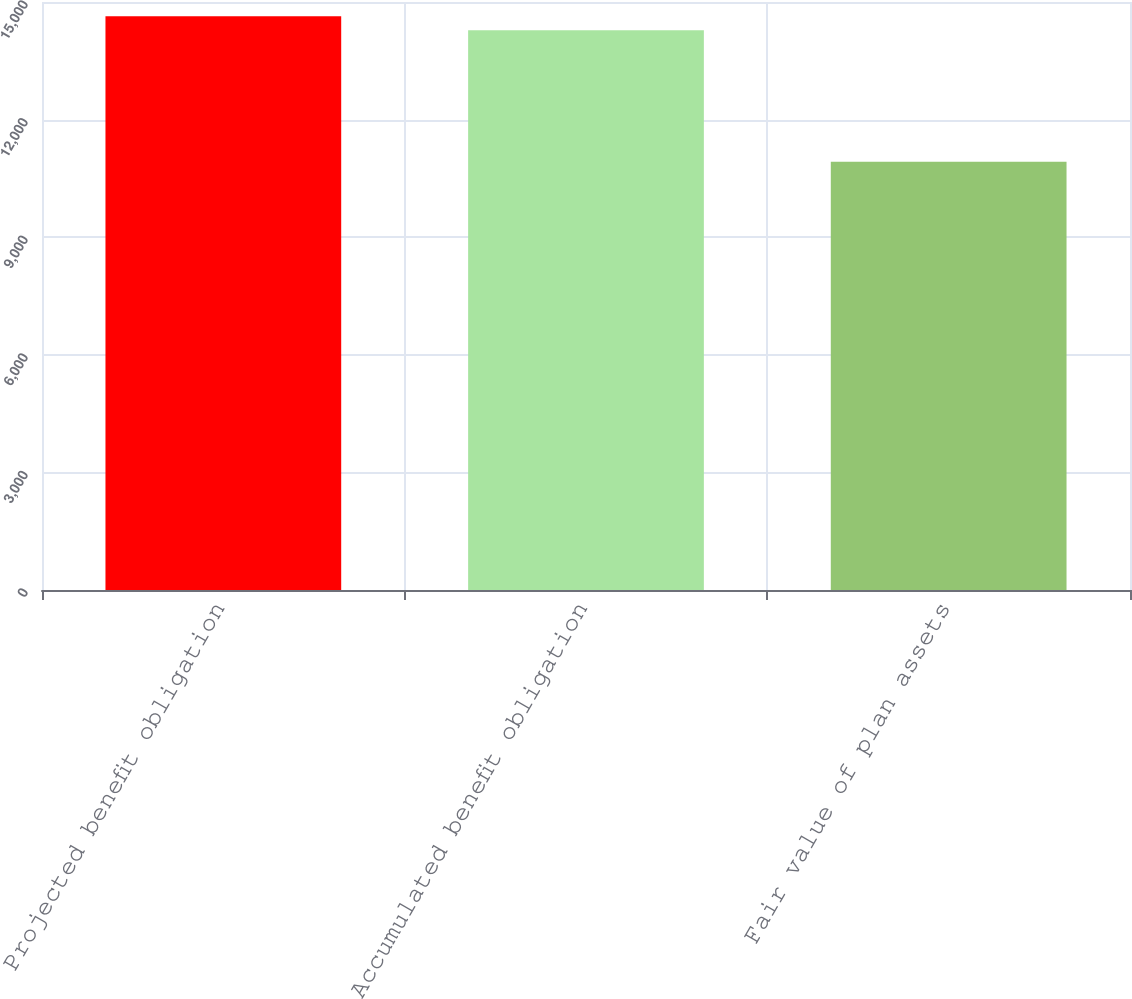Convert chart to OTSL. <chart><loc_0><loc_0><loc_500><loc_500><bar_chart><fcel>Projected benefit obligation<fcel>Accumulated benefit obligation<fcel>Fair value of plan assets<nl><fcel>14633.5<fcel>14282<fcel>10923<nl></chart> 